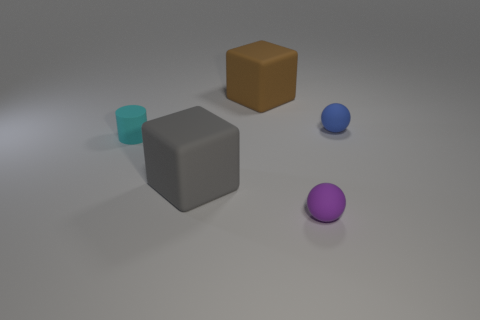Add 4 large brown shiny blocks. How many objects exist? 9 Add 2 spheres. How many spheres are left? 4 Add 1 tiny brown rubber blocks. How many tiny brown rubber blocks exist? 1 Subtract 0 green spheres. How many objects are left? 5 Subtract all cylinders. How many objects are left? 4 Subtract all big rubber things. Subtract all rubber cubes. How many objects are left? 1 